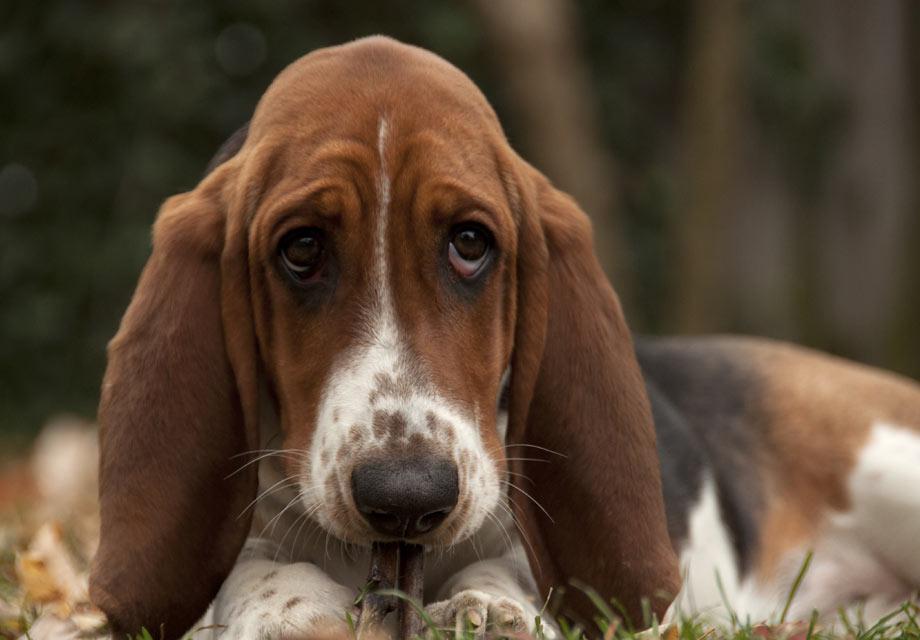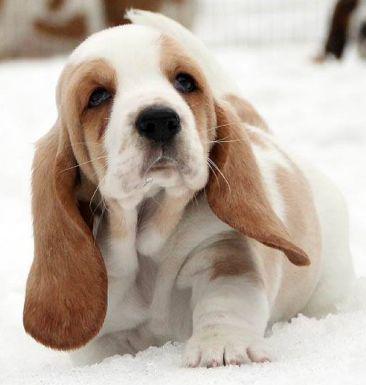The first image is the image on the left, the second image is the image on the right. For the images shown, is this caption "Exactly one dog tongue can be seen in one of the images." true? Answer yes or no. No. 